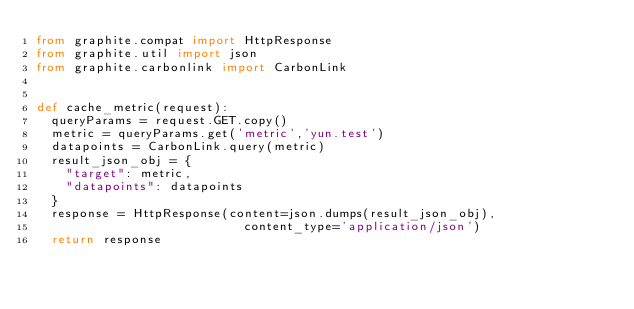Convert code to text. <code><loc_0><loc_0><loc_500><loc_500><_Python_>from graphite.compat import HttpResponse
from graphite.util import json
from graphite.carbonlink import CarbonLink


def cache_metric(request):
	queryParams = request.GET.copy()
	metric = queryParams.get('metric','yun.test')
	datapoints = CarbonLink.query(metric)
	result_json_obj = {
		"target": metric,
		"datapoints": datapoints
	}
	response = HttpResponse(content=json.dumps(result_json_obj),
                            content_type='application/json')
	return response</code> 